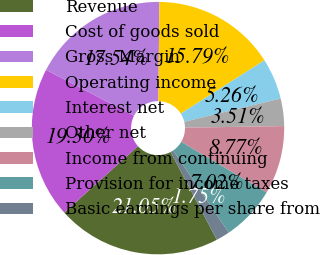<chart> <loc_0><loc_0><loc_500><loc_500><pie_chart><fcel>Revenue<fcel>Cost of goods sold<fcel>Gross Margin<fcel>Operating income<fcel>Interest net<fcel>Other net<fcel>Income from continuing<fcel>Provision for income taxes<fcel>Basic earnings per share from<nl><fcel>21.05%<fcel>19.3%<fcel>17.54%<fcel>15.79%<fcel>5.26%<fcel>3.51%<fcel>8.77%<fcel>7.02%<fcel>1.75%<nl></chart> 